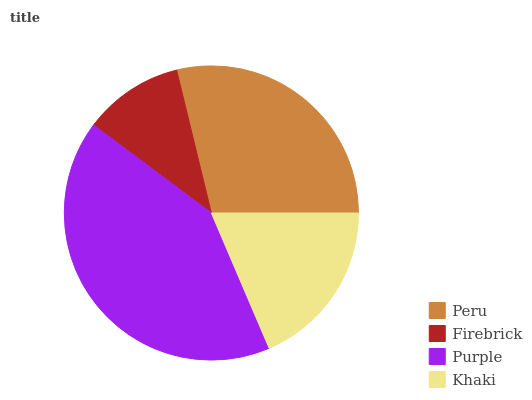Is Firebrick the minimum?
Answer yes or no. Yes. Is Purple the maximum?
Answer yes or no. Yes. Is Purple the minimum?
Answer yes or no. No. Is Firebrick the maximum?
Answer yes or no. No. Is Purple greater than Firebrick?
Answer yes or no. Yes. Is Firebrick less than Purple?
Answer yes or no. Yes. Is Firebrick greater than Purple?
Answer yes or no. No. Is Purple less than Firebrick?
Answer yes or no. No. Is Peru the high median?
Answer yes or no. Yes. Is Khaki the low median?
Answer yes or no. Yes. Is Khaki the high median?
Answer yes or no. No. Is Peru the low median?
Answer yes or no. No. 